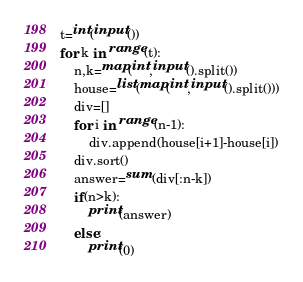<code> <loc_0><loc_0><loc_500><loc_500><_Python_>t=int(input())
for k in range(t):
    n,k=map(int,input().split())
    house=list(map(int,input().split()))
    div=[]
    for i in range(n-1):
        div.append(house[i+1]-house[i])
    div.sort()
    answer=sum(div[:n-k])
    if(n>k):
        print(answer)
    else:
        print(0)
</code> 